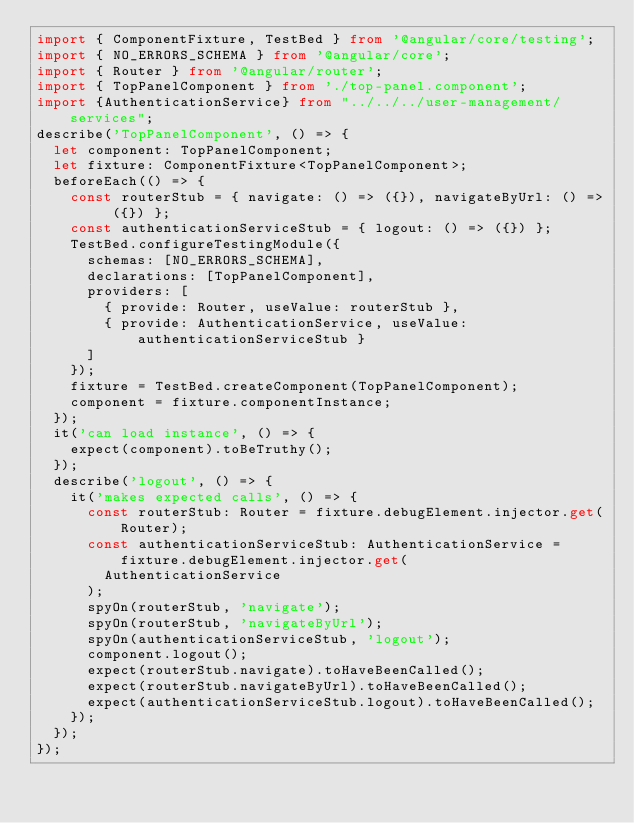Convert code to text. <code><loc_0><loc_0><loc_500><loc_500><_TypeScript_>import { ComponentFixture, TestBed } from '@angular/core/testing';
import { NO_ERRORS_SCHEMA } from '@angular/core';
import { Router } from '@angular/router';
import { TopPanelComponent } from './top-panel.component';
import {AuthenticationService} from "../../../user-management/services";
describe('TopPanelComponent', () => {
  let component: TopPanelComponent;
  let fixture: ComponentFixture<TopPanelComponent>;
  beforeEach(() => {
    const routerStub = { navigate: () => ({}), navigateByUrl: () => ({}) };
    const authenticationServiceStub = { logout: () => ({}) };
    TestBed.configureTestingModule({
      schemas: [NO_ERRORS_SCHEMA],
      declarations: [TopPanelComponent],
      providers: [
        { provide: Router, useValue: routerStub },
        { provide: AuthenticationService, useValue: authenticationServiceStub }
      ]
    });
    fixture = TestBed.createComponent(TopPanelComponent);
    component = fixture.componentInstance;
  });
  it('can load instance', () => {
    expect(component).toBeTruthy();
  });
  describe('logout', () => {
    it('makes expected calls', () => {
      const routerStub: Router = fixture.debugElement.injector.get(Router);
      const authenticationServiceStub: AuthenticationService = fixture.debugElement.injector.get(
        AuthenticationService
      );
      spyOn(routerStub, 'navigate');
      spyOn(routerStub, 'navigateByUrl');
      spyOn(authenticationServiceStub, 'logout');
      component.logout();
      expect(routerStub.navigate).toHaveBeenCalled();
      expect(routerStub.navigateByUrl).toHaveBeenCalled();
      expect(authenticationServiceStub.logout).toHaveBeenCalled();
    });
  });
});
</code> 